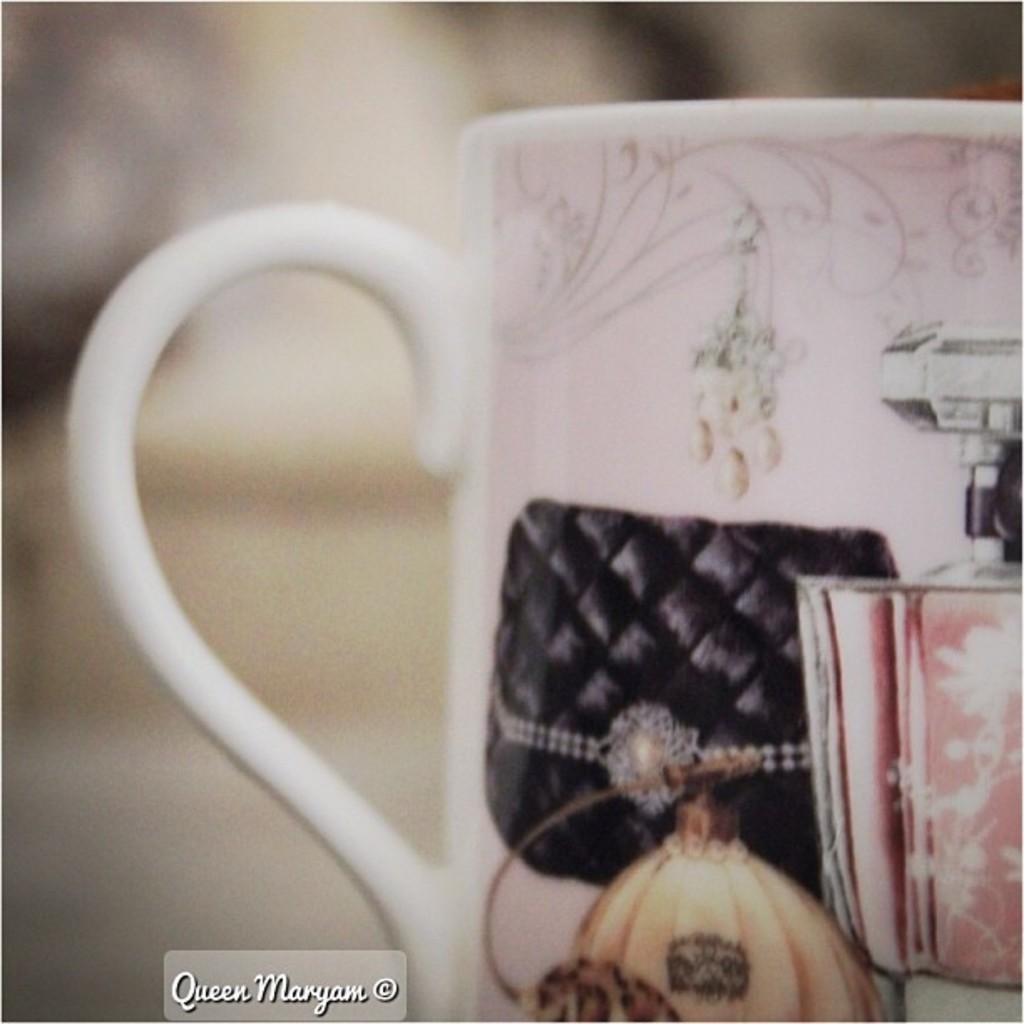What type of container is visible in the image? There is a cup with a handle in the image. Can you describe any additional features of the cup? Unfortunately, the provided facts do not mention any other features of the cup. Is there any text or design visible on the cup? The facts do not mention any text or design on the cup. What can be seen in the background of the image? The provided facts do not mention any background elements in the image. What type of cemetery can be seen in the background of the image? There is no cemetery present in the image; the provided facts only mention a cup with a handle. How does the disease affect the hair of the person in the image? There is no person or disease mentioned in the provided facts; the image only contains a cup with a handle. 